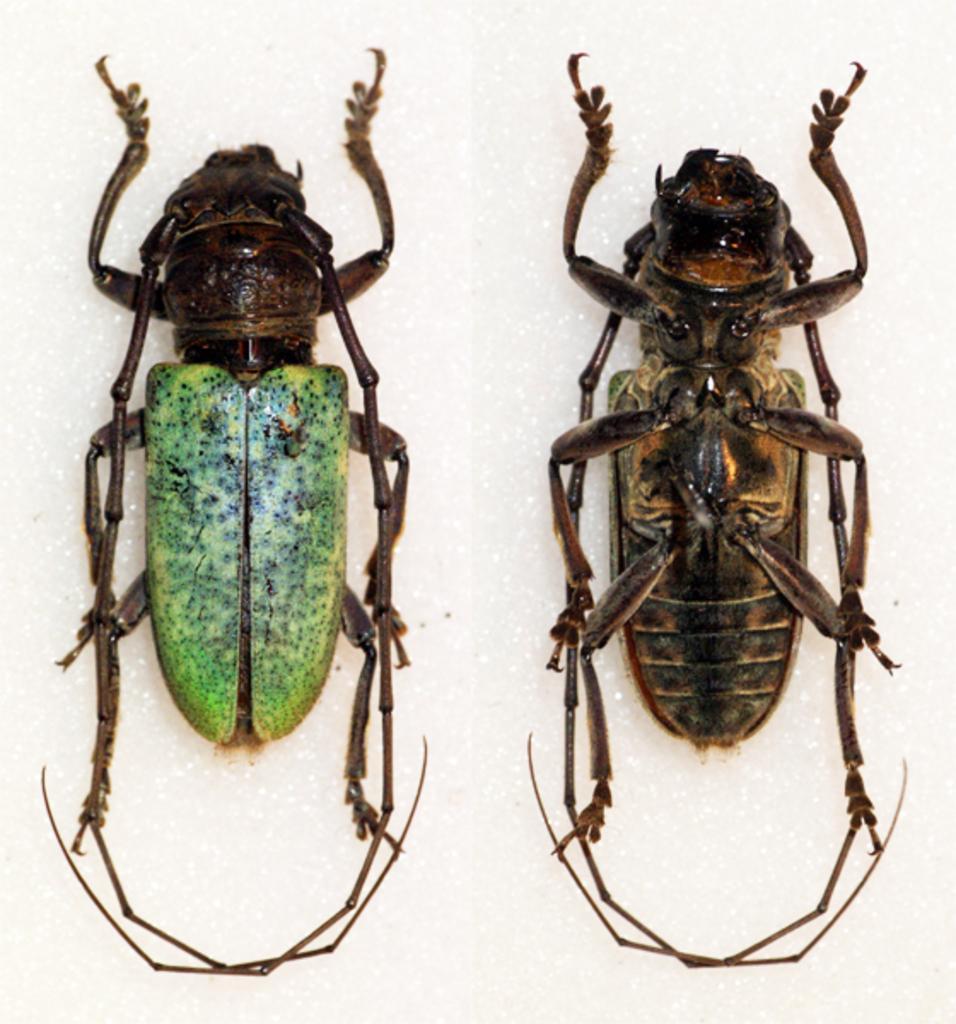Can you describe this image briefly? In this image there are two cockroaches on the floor. 